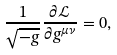Convert formula to latex. <formula><loc_0><loc_0><loc_500><loc_500>\frac { 1 } { \sqrt { - g } } \frac { \partial \mathcal { L } } { \partial g ^ { \mu \nu } } = 0 ,</formula> 